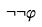<formula> <loc_0><loc_0><loc_500><loc_500>\neg \neg \varphi</formula> 